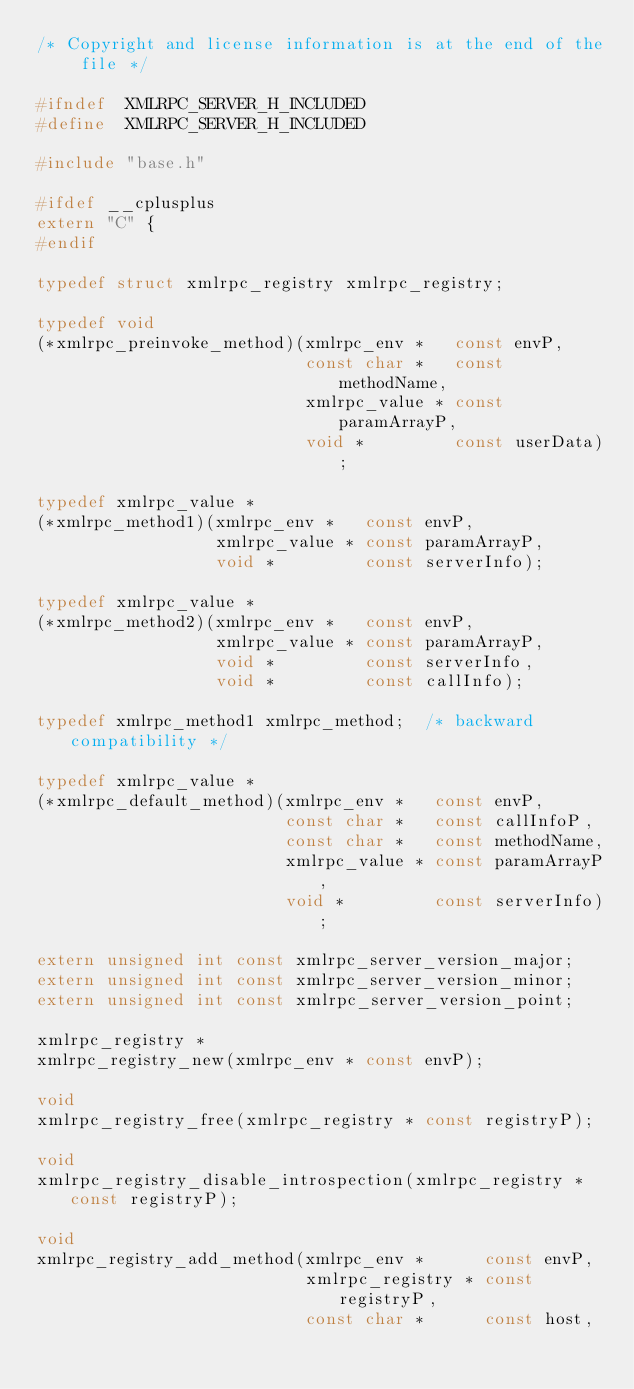Convert code to text. <code><loc_0><loc_0><loc_500><loc_500><_C_>/* Copyright and license information is at the end of the file */

#ifndef  XMLRPC_SERVER_H_INCLUDED
#define  XMLRPC_SERVER_H_INCLUDED

#include "base.h"

#ifdef __cplusplus
extern "C" {
#endif

typedef struct xmlrpc_registry xmlrpc_registry;

typedef void
(*xmlrpc_preinvoke_method)(xmlrpc_env *   const envP,
                           const char *   const methodName,
                           xmlrpc_value * const paramArrayP,
                           void *         const userData);

typedef xmlrpc_value *
(*xmlrpc_method1)(xmlrpc_env *   const envP,
                  xmlrpc_value * const paramArrayP,
                  void *         const serverInfo);

typedef xmlrpc_value *
(*xmlrpc_method2)(xmlrpc_env *   const envP,
                  xmlrpc_value * const paramArrayP,
                  void *         const serverInfo,
                  void *         const callInfo);

typedef xmlrpc_method1 xmlrpc_method;  /* backward compatibility */

typedef xmlrpc_value *
(*xmlrpc_default_method)(xmlrpc_env *   const envP,
                         const char *   const callInfoP,
                         const char *   const methodName,
                         xmlrpc_value * const paramArrayP,
                         void *         const serverInfo);

extern unsigned int const xmlrpc_server_version_major;
extern unsigned int const xmlrpc_server_version_minor;
extern unsigned int const xmlrpc_server_version_point;

xmlrpc_registry *
xmlrpc_registry_new(xmlrpc_env * const envP);

void
xmlrpc_registry_free(xmlrpc_registry * const registryP);

void
xmlrpc_registry_disable_introspection(xmlrpc_registry * const registryP);

void
xmlrpc_registry_add_method(xmlrpc_env *      const envP,
                           xmlrpc_registry * const registryP,
                           const char *      const host,</code> 